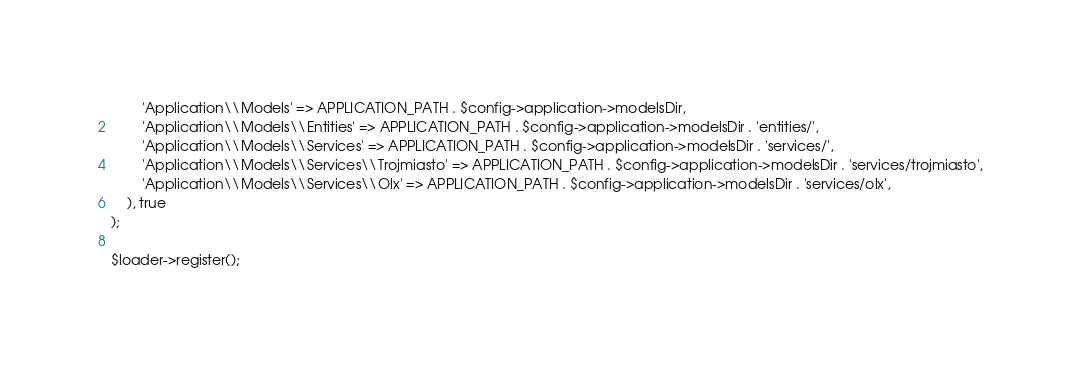<code> <loc_0><loc_0><loc_500><loc_500><_PHP_>		'Application\\Models' => APPLICATION_PATH . $config->application->modelsDir,
		'Application\\Models\\Entities' => APPLICATION_PATH . $config->application->modelsDir . 'entities/',
		'Application\\Models\\Services' => APPLICATION_PATH . $config->application->modelsDir . 'services/',
		'Application\\Models\\Services\\Trojmiasto' => APPLICATION_PATH . $config->application->modelsDir . 'services/trojmiasto',
		'Application\\Models\\Services\\Olx' => APPLICATION_PATH . $config->application->modelsDir . 'services/olx',
	), true
);

$loader->register();</code> 